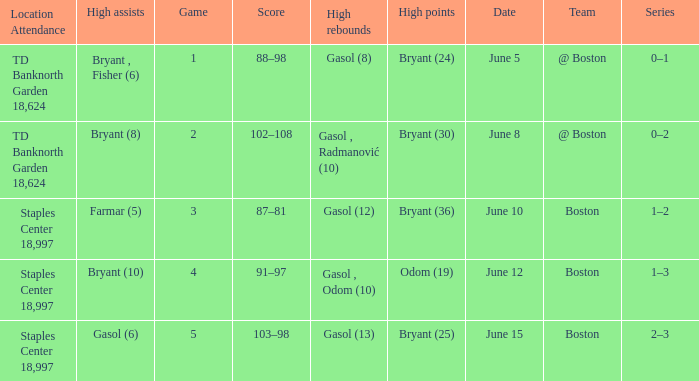Name the location on june 10 Staples Center 18,997. 